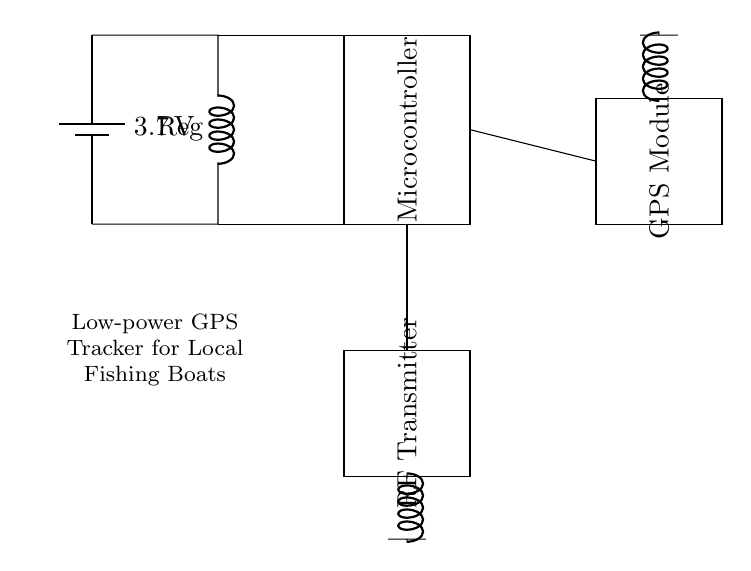What is the power supply voltage? The power supply voltage is identified at the battery symbol on the left side of the circuit diagram. It is marked as 3.7 volts.
Answer: 3.7 volts What component regulates the voltage? The component that regulates the voltage is labeled as "Reg" and is represented by an inductor symbol in the circuit. This indicates its function as a voltage regulator in the system.
Answer: Reg Which component is responsible for tracking location? The component responsible for tracking location is labeled as "GPS Module" in the circuit diagram, indicating its function in receiving location data.
Answer: GPS Module How many main functional blocks are in the circuit? The main functional blocks in the circuit include the Power Supply, Microcontroller, GPS Module, and RF Transmitter, totaling four separate functional sections in the design.
Answer: Four What is the purpose of the RF Transmitter in this circuit? The RF Transmitter in this circuit is used to send the tracked location data from the microcontroller wirelessly to a receiver, which is essential for remote monitoring of the fishing boat's location.
Answer: Send location data What is the connection between the Microcontroller and the GPS Module? The connection between the Microcontroller and the GPS Module is established by a wire leading from the Microcontroller directly to the GPS Module, indicating that the microcontroller communicates with the GPS module to obtain location data.
Answer: Direct communication wire What role does the antenna play in this circuit? The antenna is connected to both the RF Transmitter and the GPS Module, serving the purpose of transmitting RF signals and receiving GPS signals, respectively, making it crucial for data communication both ways.
Answer: Transmit and receive signals 